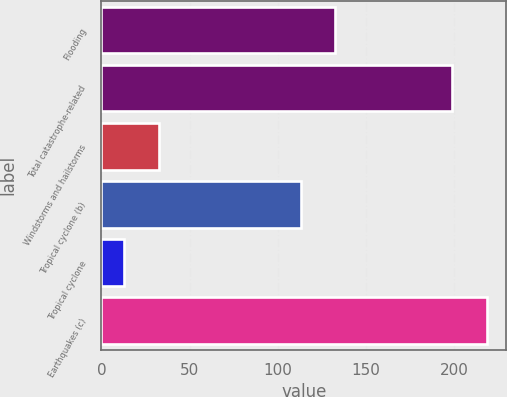Convert chart to OTSL. <chart><loc_0><loc_0><loc_500><loc_500><bar_chart><fcel>Flooding<fcel>Total catastrophe-related<fcel>Windstorms and hailstorms<fcel>Tropical cyclone (b)<fcel>Tropical cyclone<fcel>Earthquakes (c)<nl><fcel>132.6<fcel>199<fcel>32.6<fcel>113<fcel>13<fcel>218.6<nl></chart> 